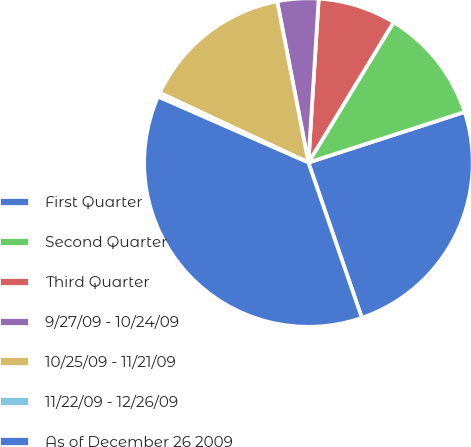Convert chart. <chart><loc_0><loc_0><loc_500><loc_500><pie_chart><fcel>First Quarter<fcel>Second Quarter<fcel>Third Quarter<fcel>9/27/09 - 10/24/09<fcel>10/25/09 - 11/21/09<fcel>11/22/09 - 12/26/09<fcel>As of December 26 2009<nl><fcel>24.71%<fcel>11.33%<fcel>7.69%<fcel>4.04%<fcel>14.98%<fcel>0.4%<fcel>36.85%<nl></chart> 